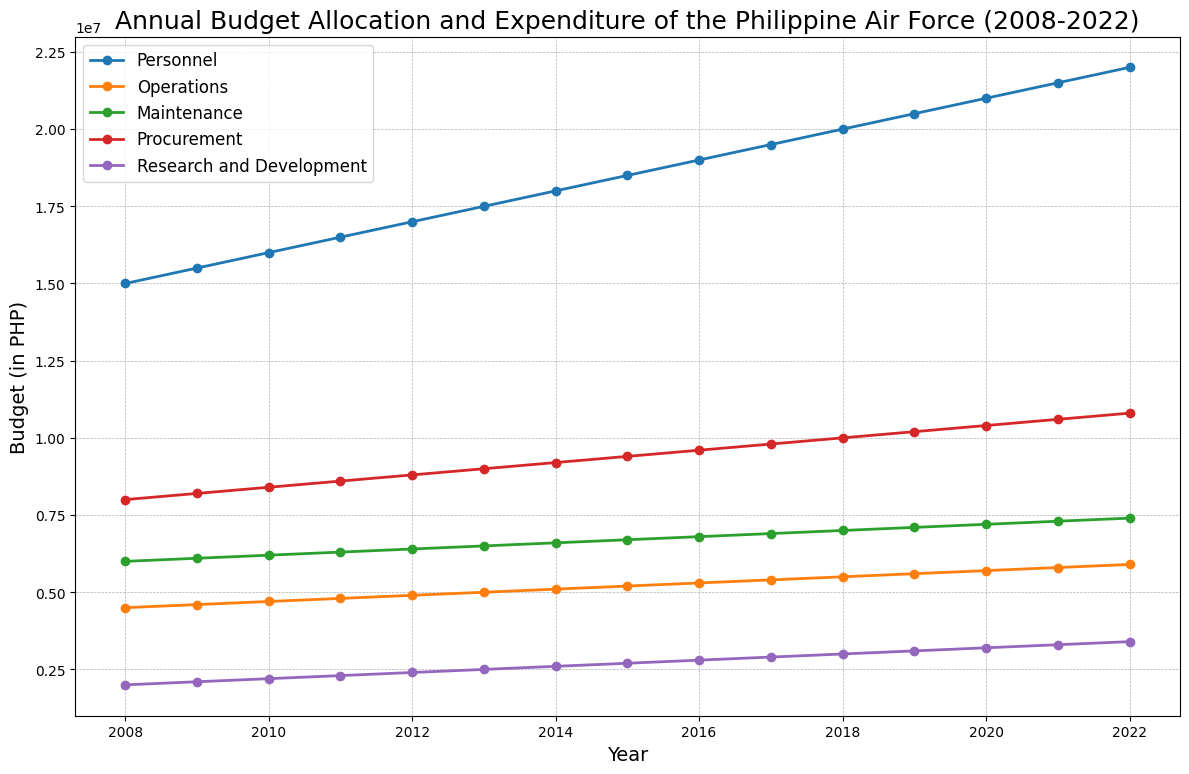What year saw the highest budget allocation for procurement? To find the highest budget allocation for procurement, look at the plot for the "Procurement" line and identify the year where this line is at its highest point.
Answer: 2022 How much more was allocated to Personnel than to Operations in 2015? Look at the "Personnel" and "Operations" lines for the year 2015 and find the values. Subtract the Operations value from the Personnel value: 18,500,000 - 5,200,000 = 13,300,000.
Answer: 13,300,000 Which category experienced the most significant increase in budget allocation between 2008 and 2022? Compare the differences between the 2008 and 2022 values for each category by observing the changes in the heights of the lines. The Procurement category increased from 8,000,000 to 10,800,000, a significant increase.
Answer: Procurement How has the budget allocation for Research and Development changed over the years? Look at the "Research and Development" line and note the trend over time. It steadily increases from 2,000,000 in 2008 to 3,400,000 in 2022.
Answer: Steady increase What is the total budget allocation in 2014 across all categories? Add up the budget values for all categories in 2014: Personnel (18,000,000) + Operations (5,100,000) + Maintenance (6,600,000) + Procurement (9,200,000) + Research and Development (2,600,000). This equals 18,000,000 + 5,100,000 + 6,600,000 + 9,200,000 + 2,600,000 = 41,500,000.
Answer: 41,500,000 Which category consistently received the lowest budget allocation over the years? By observing the plot and comparing the heights of the lines, the "Research and Development" category consistently has the lowest budget allocation across all years.
Answer: Research and Development What trends can you observe in the Operations budget allocation from 2008 to 2022? Observe the "Operations" line; it increases gradually from 4,500,000 in 2008 to 5,900,000 in 2022, showing a steady upward trend.
Answer: Steady upward trend 